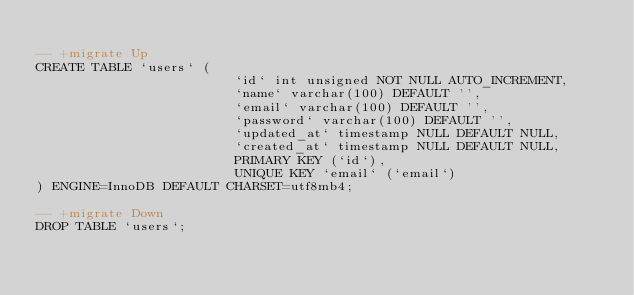Convert code to text. <code><loc_0><loc_0><loc_500><loc_500><_SQL_>
-- +migrate Up
CREATE TABLE `users` (
                         `id` int unsigned NOT NULL AUTO_INCREMENT,
                         `name` varchar(100) DEFAULT '',
                         `email` varchar(100) DEFAULT '',
                         `password` varchar(100) DEFAULT '',
                         `updated_at` timestamp NULL DEFAULT NULL,
                         `created_at` timestamp NULL DEFAULT NULL,
                         PRIMARY KEY (`id`),
                         UNIQUE KEY `email` (`email`)
) ENGINE=InnoDB DEFAULT CHARSET=utf8mb4;

-- +migrate Down
DROP TABLE `users`;
</code> 